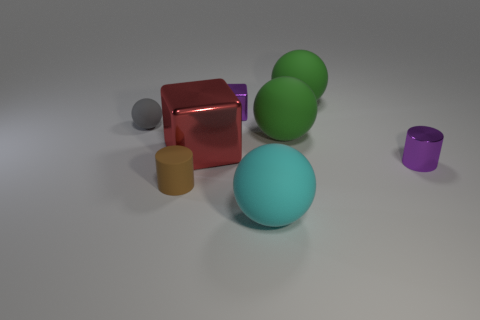Are there any cyan rubber spheres behind the small rubber cylinder?
Your response must be concise. No. There is a shiny cylinder that is in front of the large thing left of the purple shiny block that is behind the small purple metallic cylinder; what color is it?
Your answer should be very brief. Purple. What is the shape of the purple metallic thing that is the same size as the purple block?
Give a very brief answer. Cylinder. Is the number of brown matte cylinders greater than the number of large cyan cubes?
Your answer should be compact. Yes. There is a metal cube on the right side of the red object; are there any small purple cylinders that are behind it?
Your response must be concise. No. What is the color of the other small thing that is the same shape as the cyan thing?
Your answer should be compact. Gray. Is there anything else that is the same shape as the red thing?
Your response must be concise. Yes. The small cylinder that is the same material as the gray ball is what color?
Your response must be concise. Brown. There is a tiny object in front of the cylinder that is on the right side of the tiny brown rubber cylinder; are there any small metal cubes that are in front of it?
Provide a short and direct response. No. Is the number of matte cylinders that are to the right of the brown rubber cylinder less than the number of purple metallic cylinders that are to the left of the red object?
Offer a terse response. No. 